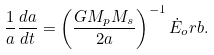<formula> <loc_0><loc_0><loc_500><loc_500>\frac { 1 } { a } \frac { d a } { d t } = \left ( \frac { G M _ { p } M _ { s } } { 2 a } \right ) ^ { - 1 } \dot { E } _ { o } r b .</formula> 